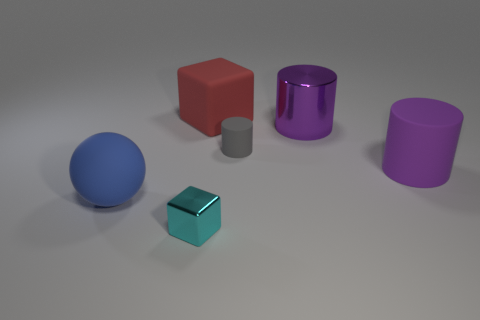Are there any small objects made of the same material as the large blue thing?
Your answer should be compact. Yes. What number of rubber objects are either blocks or large balls?
Provide a short and direct response. 2. The thing in front of the large rubber thing left of the large red matte object is what shape?
Your response must be concise. Cube. Is the number of small cyan blocks behind the tiny cylinder less than the number of brown metallic things?
Give a very brief answer. No. What is the shape of the blue object?
Offer a terse response. Sphere. There is a rubber cylinder to the left of the large purple matte cylinder; what size is it?
Make the answer very short. Small. What color is the cube that is the same size as the purple rubber cylinder?
Give a very brief answer. Red. Is there a big thing that has the same color as the large matte cylinder?
Provide a succinct answer. Yes. Is the number of blue rubber balls in front of the small cyan thing less than the number of rubber blocks in front of the sphere?
Make the answer very short. No. The thing that is behind the tiny metal block and to the left of the large block is made of what material?
Your answer should be very brief. Rubber. 